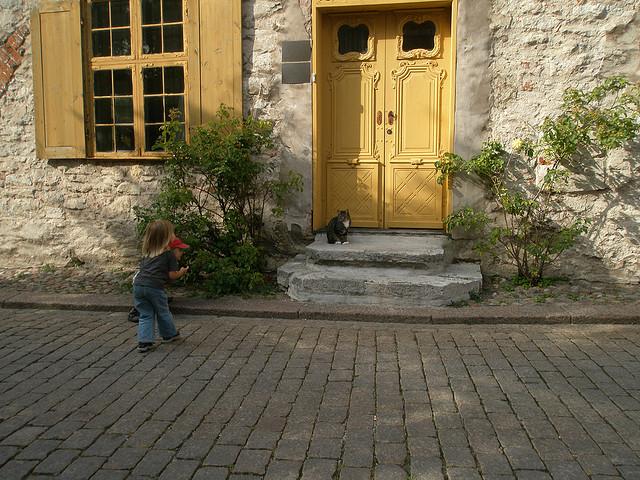Do the children want to see the cat?
Be succinct. Yes. How many different colors are there in the image?
Give a very brief answer. 7. What color is the door?
Give a very brief answer. Yellow. What is on the person's hands?
Quick response, please. Nothing. Is this boy old enough to be walking alone?
Give a very brief answer. No. What animal is in front of the door?
Short answer required. Cat. Is the wall dirty?
Quick response, please. No. What direction is the door facing?
Write a very short answer. South. 